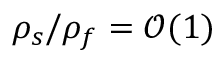<formula> <loc_0><loc_0><loc_500><loc_500>\rho _ { s } / \rho _ { f } = \mathcal { O } ( 1 )</formula> 